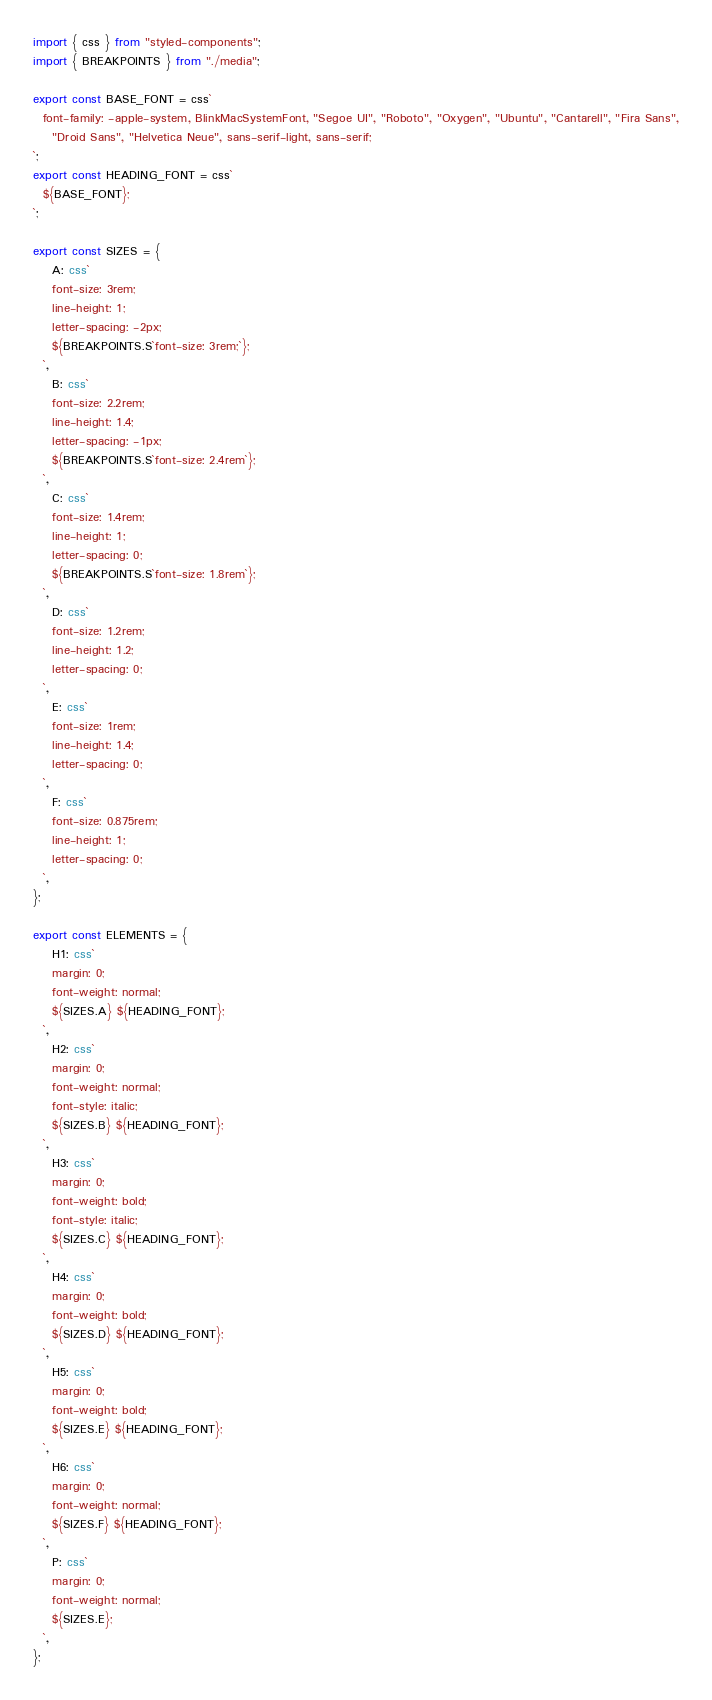Convert code to text. <code><loc_0><loc_0><loc_500><loc_500><_TypeScript_>import { css } from "styled-components";
import { BREAKPOINTS } from "./media";

export const BASE_FONT = css`
  font-family: -apple-system, BlinkMacSystemFont, "Segoe UI", "Roboto", "Oxygen", "Ubuntu", "Cantarell", "Fira Sans",
    "Droid Sans", "Helvetica Neue", sans-serif-light, sans-serif;
`;
export const HEADING_FONT = css`
  ${BASE_FONT};
`;

export const SIZES = {
    A: css`
    font-size: 3rem;
    line-height: 1;
    letter-spacing: -2px;
    ${BREAKPOINTS.S`font-size: 3rem;`};
  `,
    B: css`
    font-size: 2.2rem;
    line-height: 1.4;
    letter-spacing: -1px;
    ${BREAKPOINTS.S`font-size: 2.4rem`};
  `,
    C: css`
    font-size: 1.4rem;
    line-height: 1;
    letter-spacing: 0;
    ${BREAKPOINTS.S`font-size: 1.8rem`};
  `,
    D: css`
    font-size: 1.2rem;
    line-height: 1.2;
    letter-spacing: 0;
  `,
    E: css`
    font-size: 1rem;
    line-height: 1.4;
    letter-spacing: 0;
  `,
    F: css`
    font-size: 0.875rem;
    line-height: 1;
    letter-spacing: 0;
  `,
};

export const ELEMENTS = {
    H1: css`
    margin: 0;
    font-weight: normal;
    ${SIZES.A} ${HEADING_FONT};
  `,
    H2: css`
    margin: 0;
    font-weight: normal;
    font-style: italic;
    ${SIZES.B} ${HEADING_FONT};
  `,
    H3: css`
    margin: 0;
    font-weight: bold;
    font-style: italic;
    ${SIZES.C} ${HEADING_FONT};
  `,
    H4: css`
    margin: 0;
    font-weight: bold;
    ${SIZES.D} ${HEADING_FONT};
  `,
    H5: css`
    margin: 0;
    font-weight: bold;
    ${SIZES.E} ${HEADING_FONT};
  `,
    H6: css`
    margin: 0;
    font-weight: normal;
    ${SIZES.F} ${HEADING_FONT};
  `,
    P: css`
    margin: 0;
    font-weight: normal;
    ${SIZES.E};
  `,
};
</code> 